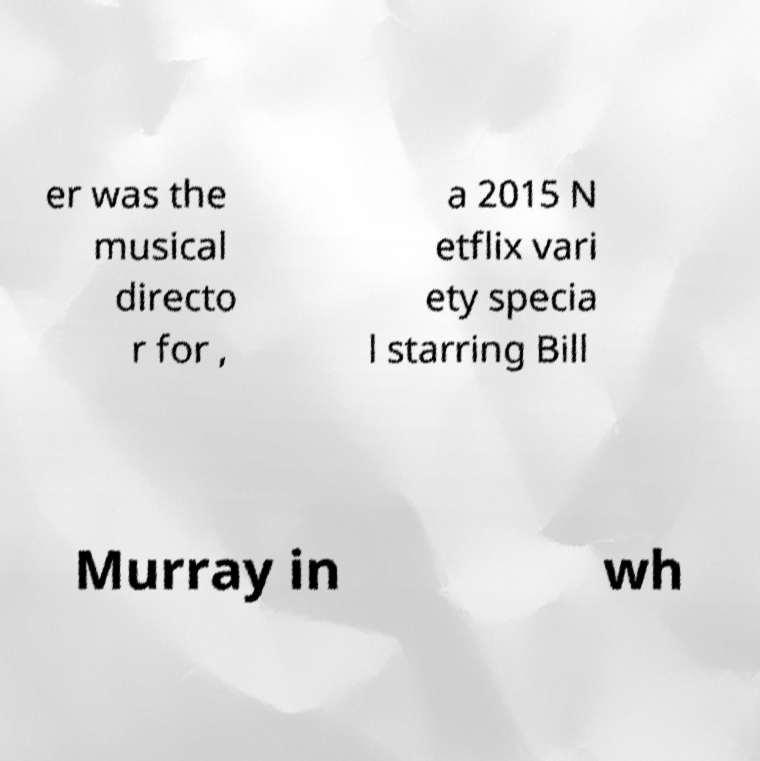I need the written content from this picture converted into text. Can you do that? er was the musical directo r for , a 2015 N etflix vari ety specia l starring Bill Murray in wh 